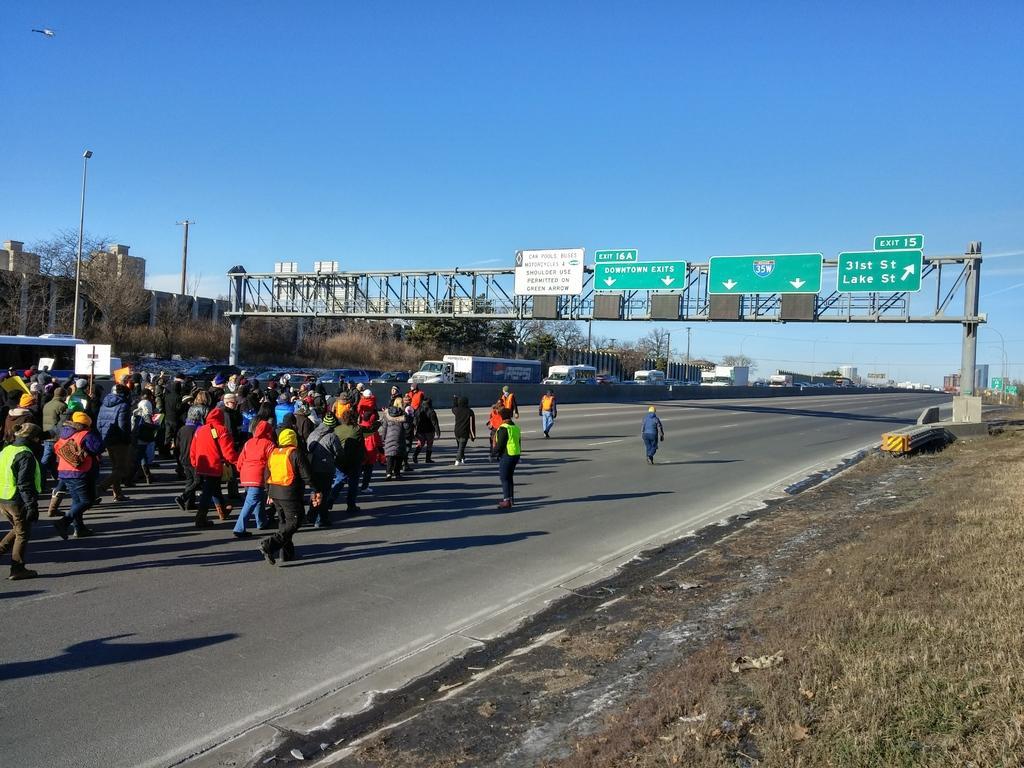How would you summarize this image in a sentence or two? In this picture I can see there are a group of people jogging on the road and they are wearing coats and there is a arch here and it has direction boards and there are trees here on to left and there are buildings, trucks on the road and trees and the sky is clear. 